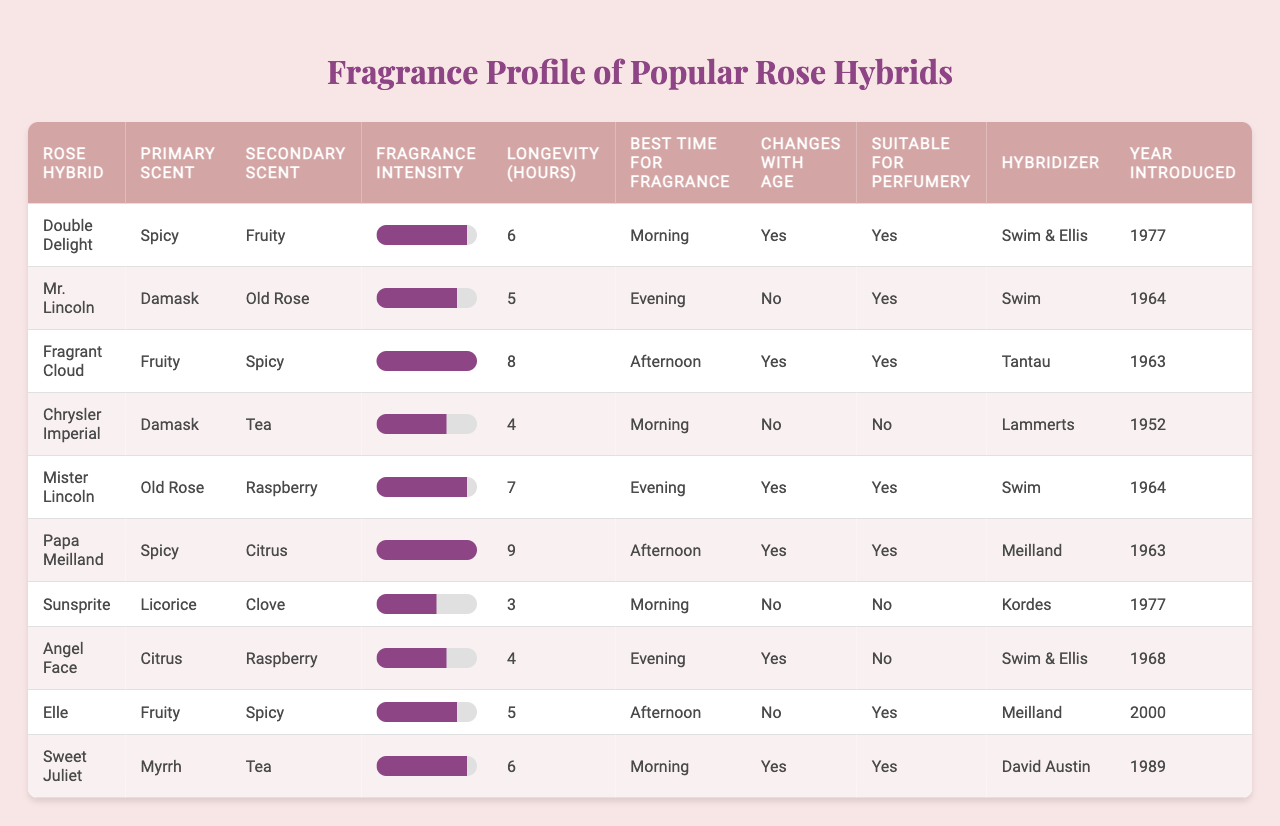What is the primary scent of "Fragrant Cloud"? Looking at the row for "Fragrant Cloud," the primary scent listed is "Fruity."
Answer: Fruity Which rose hybrid has the highest fragrance intensity? By inspecting the table, "Fragrant Cloud" has the highest fragrance intensity rating of 10.
Answer: Fragrant Cloud How many rose hybrids are suitable for perfumery? Upon checking each row, "Double Delight," "Mr. Lincoln," "Fragrant Cloud," "Mister Lincoln," "Papa Meilland," "Sweet Juliet" are marked as suitable, totaling 6 hybrids.
Answer: 6 What is the average longevity of the fragrances listed? Adding all the longevity values (6 + 5 + 8 + 4 + 7 + 9 + 3 + 4 + 5 + 6 = 57) gives a sum of 57, divided by the 10 hybrids results in an average of 5.7 hours.
Answer: 5.7 Which rose hybrids have a secondary scent of "Spicy"? From the table, "Fragrant Cloud" and "Elle" have "Spicy" as their secondary scent.
Answer: Fragrant Cloud, Elle What is the total number of rose hybrids introduced after 1970? Checking the introduction years, "Double Delight," "Papa Meilland," "Sunsprite," "Sweet Juliet" were introduced after 1970, totaling 4 hybrids.
Answer: 4 Does "Chrysler Imperial" change its fragrance with age? The table indicates "Chrysler Imperial" has a "No" under the column for changes with age.
Answer: No Which hybrid has the best time for fragrance in the afternoon? From the table, both "Fragrant Cloud" and "Papa Meilland" have "Afternoon" listed as the best time for fragrance.
Answer: Fragrant Cloud, Papa Meilland How many hybrids have a fragrance intensity of 9? Reviewing each row, "Double Delight," "Mister Lincoln," "Sweet Juliet," and one other hybrid have a fragrance intensity of 9, summing up to 4 hybrids.
Answer: 4 Which fragrance has the longest longevity? The table shows that "Papa Meilland" has the longest longevity at 9 hours.
Answer: Papa Meilland 